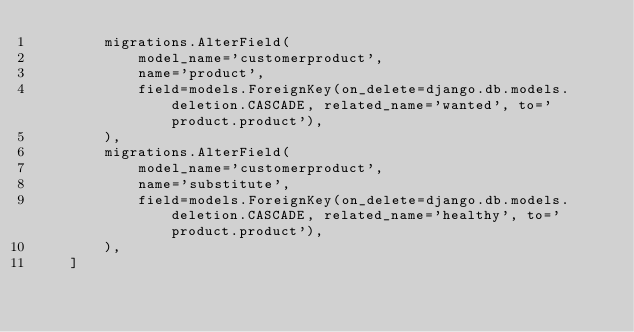<code> <loc_0><loc_0><loc_500><loc_500><_Python_>        migrations.AlterField(
            model_name='customerproduct',
            name='product',
            field=models.ForeignKey(on_delete=django.db.models.deletion.CASCADE, related_name='wanted', to='product.product'),
        ),
        migrations.AlterField(
            model_name='customerproduct',
            name='substitute',
            field=models.ForeignKey(on_delete=django.db.models.deletion.CASCADE, related_name='healthy', to='product.product'),
        ),
    ]
</code> 